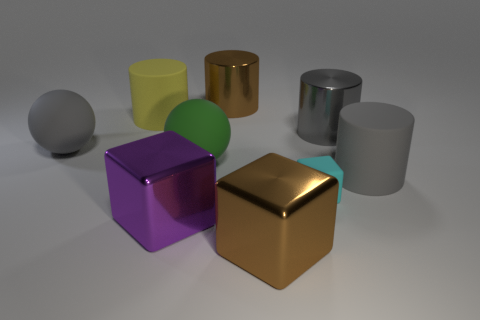Are there any other blocks that have the same color as the matte cube?
Your response must be concise. No. There is a metal object left of the green thing; is there a large purple metallic object on the right side of it?
Provide a succinct answer. No. There is a yellow cylinder; is its size the same as the thing left of the big yellow rubber thing?
Ensure brevity in your answer.  Yes. Are there any small cyan matte cubes in front of the matte cylinder that is to the left of the gray cylinder in front of the big green matte thing?
Give a very brief answer. Yes. There is a large gray thing that is on the left side of the purple metal cube; what is its material?
Your answer should be compact. Rubber. Does the yellow cylinder have the same size as the gray metallic cylinder?
Provide a short and direct response. Yes. What color is the big cylinder that is both right of the green rubber object and to the left of the big gray shiny cylinder?
Ensure brevity in your answer.  Brown. What shape is the small cyan thing that is made of the same material as the yellow cylinder?
Ensure brevity in your answer.  Cube. What number of brown objects are both behind the gray sphere and in front of the tiny matte object?
Offer a terse response. 0. There is a large gray rubber ball; are there any large rubber spheres on the left side of it?
Make the answer very short. No. 